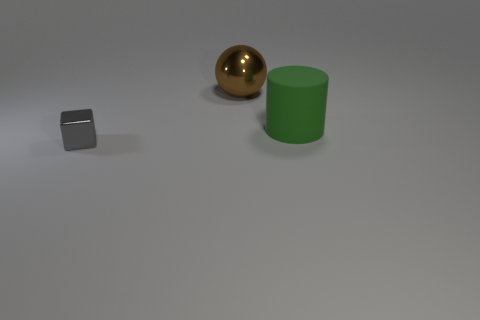How many small red objects are there?
Offer a very short reply. 0. Do the metallic object in front of the brown metallic object and the green object have the same size?
Keep it short and to the point. No. How many matte things are small gray things or large green balls?
Your answer should be compact. 0. How many big brown metal things are to the left of the large object on the right side of the brown metal ball?
Your response must be concise. 1. There is a object that is in front of the brown object and left of the green matte cylinder; what shape is it?
Keep it short and to the point. Cube. What material is the thing that is behind the object on the right side of the metal object that is right of the gray block made of?
Your response must be concise. Metal. What is the big brown ball made of?
Keep it short and to the point. Metal. Does the green cylinder have the same material as the object in front of the big green rubber cylinder?
Provide a succinct answer. No. There is a big object that is on the right side of the metallic thing right of the gray metallic object; what color is it?
Offer a terse response. Green. There is a thing that is both on the left side of the big rubber thing and on the right side of the gray block; what size is it?
Ensure brevity in your answer.  Large. 